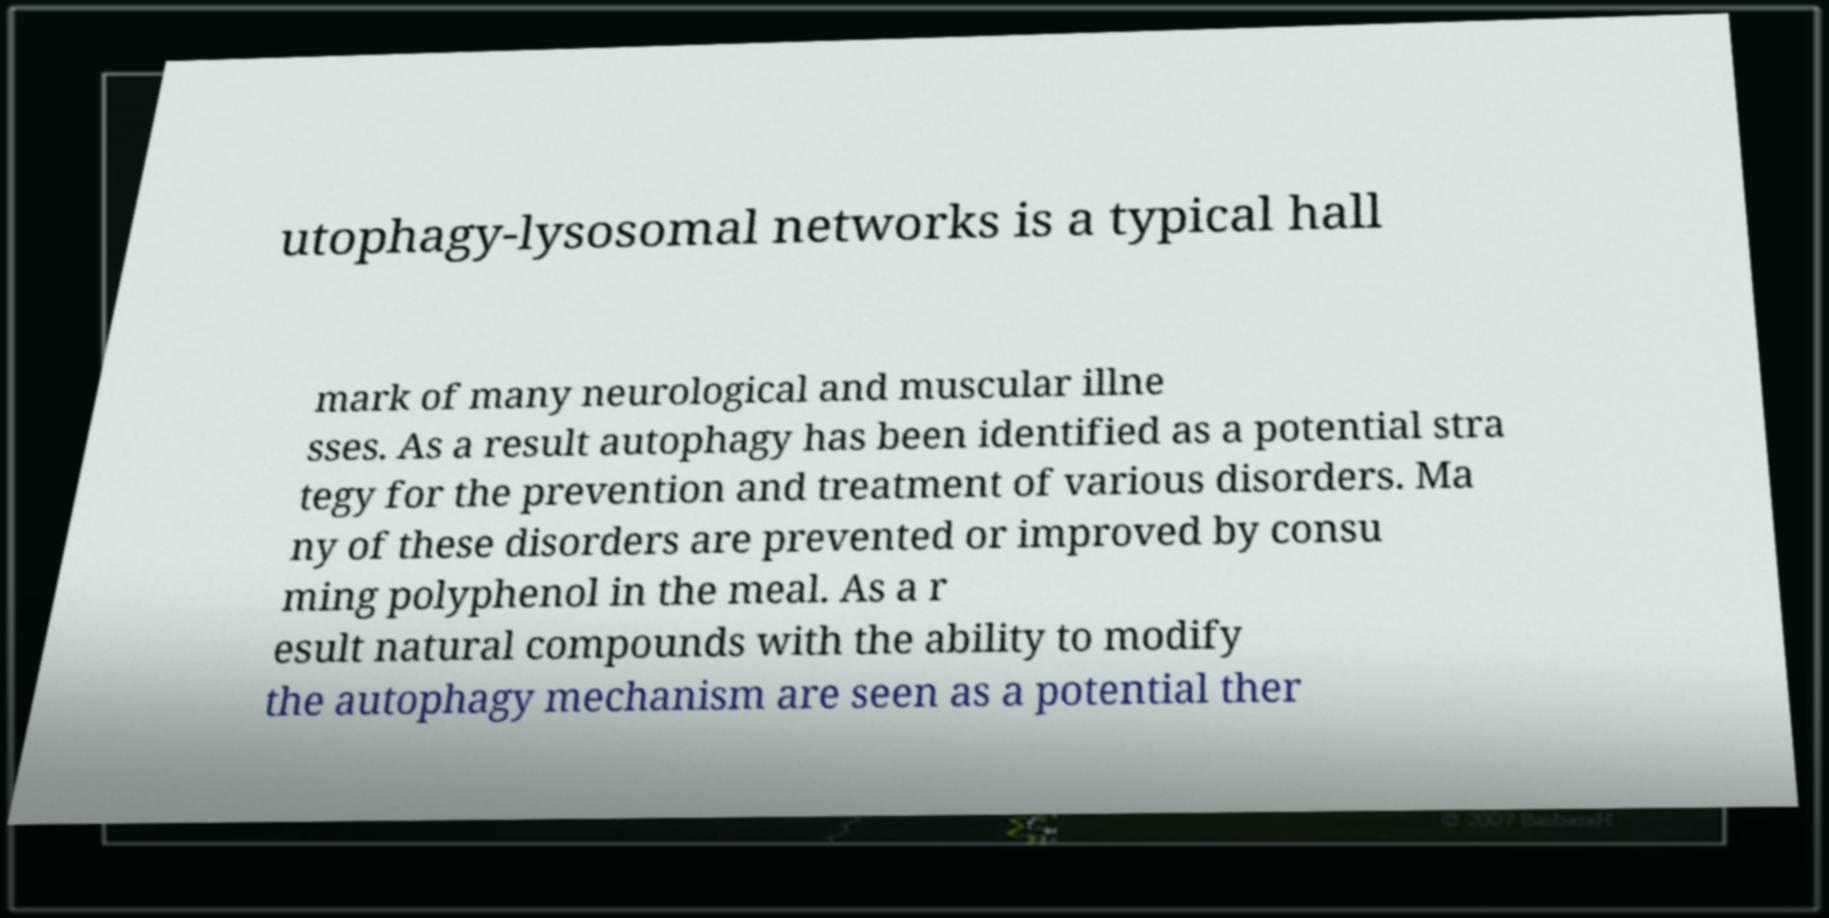Could you extract and type out the text from this image? utophagy-lysosomal networks is a typical hall mark of many neurological and muscular illne sses. As a result autophagy has been identified as a potential stra tegy for the prevention and treatment of various disorders. Ma ny of these disorders are prevented or improved by consu ming polyphenol in the meal. As a r esult natural compounds with the ability to modify the autophagy mechanism are seen as a potential ther 